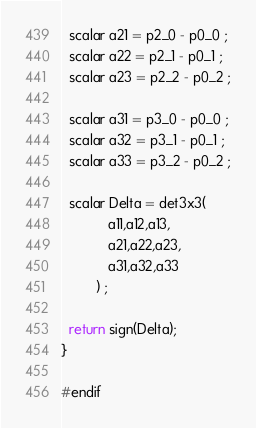Convert code to text. <code><loc_0><loc_0><loc_500><loc_500><_SQL_>  scalar a21 = p2_0 - p0_0 ;
  scalar a22 = p2_1 - p0_1 ;
  scalar a23 = p2_2 - p0_2 ;

  scalar a31 = p3_0 - p0_0 ;
  scalar a32 = p3_1 - p0_1 ;
  scalar a33 = p3_2 - p0_2 ;

  scalar Delta = det3x3(
            a11,a12,a13,
            a21,a22,a23,
            a31,a32,a33
         ) ;

  return sign(Delta);
}

#endif
</code> 